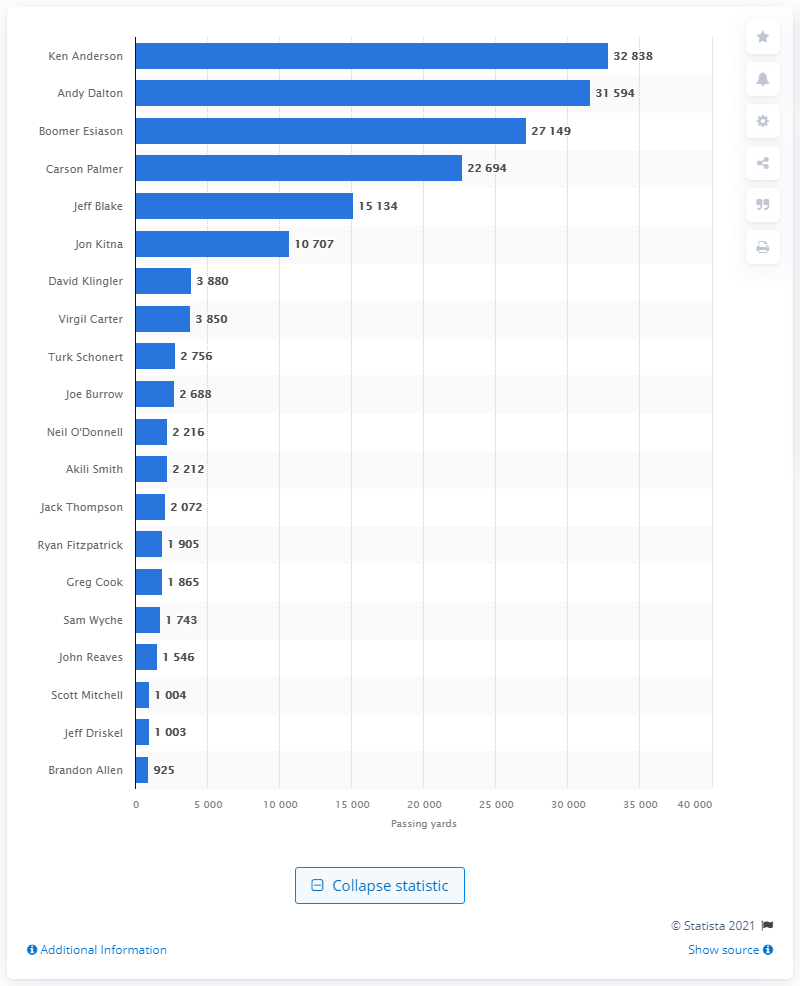Give some essential details in this illustration. Ken Anderson is the career passing leader of the Cincinnati Bengals. 